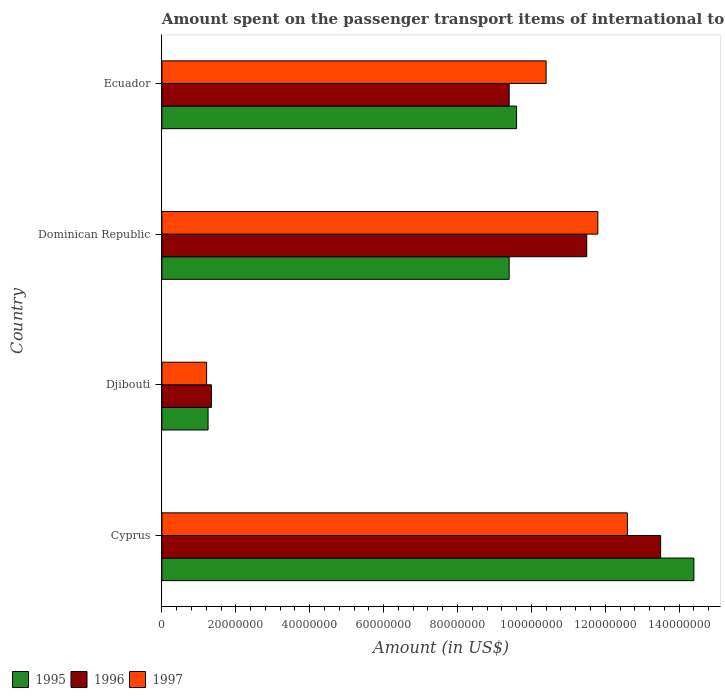How many bars are there on the 4th tick from the bottom?
Provide a succinct answer. 3. What is the label of the 2nd group of bars from the top?
Provide a succinct answer. Dominican Republic. What is the amount spent on the passenger transport items of international tourists in 1996 in Dominican Republic?
Offer a terse response. 1.15e+08. Across all countries, what is the maximum amount spent on the passenger transport items of international tourists in 1997?
Your answer should be compact. 1.26e+08. Across all countries, what is the minimum amount spent on the passenger transport items of international tourists in 1996?
Provide a short and direct response. 1.34e+07. In which country was the amount spent on the passenger transport items of international tourists in 1995 maximum?
Provide a short and direct response. Cyprus. In which country was the amount spent on the passenger transport items of international tourists in 1996 minimum?
Ensure brevity in your answer.  Djibouti. What is the total amount spent on the passenger transport items of international tourists in 1995 in the graph?
Offer a very short reply. 3.46e+08. What is the difference between the amount spent on the passenger transport items of international tourists in 1996 in Djibouti and that in Ecuador?
Provide a succinct answer. -8.06e+07. What is the difference between the amount spent on the passenger transport items of international tourists in 1997 in Cyprus and the amount spent on the passenger transport items of international tourists in 1996 in Dominican Republic?
Offer a terse response. 1.10e+07. What is the average amount spent on the passenger transport items of international tourists in 1997 per country?
Give a very brief answer. 9.00e+07. What is the difference between the amount spent on the passenger transport items of international tourists in 1997 and amount spent on the passenger transport items of international tourists in 1995 in Dominican Republic?
Keep it short and to the point. 2.40e+07. What is the ratio of the amount spent on the passenger transport items of international tourists in 1997 in Djibouti to that in Ecuador?
Your answer should be compact. 0.12. Is the amount spent on the passenger transport items of international tourists in 1996 in Cyprus less than that in Dominican Republic?
Make the answer very short. No. Is the difference between the amount spent on the passenger transport items of international tourists in 1997 in Djibouti and Ecuador greater than the difference between the amount spent on the passenger transport items of international tourists in 1995 in Djibouti and Ecuador?
Offer a very short reply. No. What is the difference between the highest and the second highest amount spent on the passenger transport items of international tourists in 1995?
Offer a terse response. 4.80e+07. What is the difference between the highest and the lowest amount spent on the passenger transport items of international tourists in 1997?
Offer a terse response. 1.14e+08. Is the sum of the amount spent on the passenger transport items of international tourists in 1995 in Djibouti and Ecuador greater than the maximum amount spent on the passenger transport items of international tourists in 1996 across all countries?
Your answer should be compact. No. How many countries are there in the graph?
Give a very brief answer. 4. What is the difference between two consecutive major ticks on the X-axis?
Offer a terse response. 2.00e+07. Are the values on the major ticks of X-axis written in scientific E-notation?
Keep it short and to the point. No. Does the graph contain any zero values?
Ensure brevity in your answer.  No. Does the graph contain grids?
Provide a short and direct response. No. How many legend labels are there?
Ensure brevity in your answer.  3. How are the legend labels stacked?
Make the answer very short. Horizontal. What is the title of the graph?
Offer a very short reply. Amount spent on the passenger transport items of international tourists. Does "1969" appear as one of the legend labels in the graph?
Make the answer very short. No. What is the Amount (in US$) of 1995 in Cyprus?
Provide a succinct answer. 1.44e+08. What is the Amount (in US$) of 1996 in Cyprus?
Your answer should be very brief. 1.35e+08. What is the Amount (in US$) of 1997 in Cyprus?
Your answer should be very brief. 1.26e+08. What is the Amount (in US$) in 1995 in Djibouti?
Keep it short and to the point. 1.25e+07. What is the Amount (in US$) of 1996 in Djibouti?
Offer a very short reply. 1.34e+07. What is the Amount (in US$) in 1997 in Djibouti?
Keep it short and to the point. 1.21e+07. What is the Amount (in US$) in 1995 in Dominican Republic?
Your answer should be very brief. 9.40e+07. What is the Amount (in US$) of 1996 in Dominican Republic?
Keep it short and to the point. 1.15e+08. What is the Amount (in US$) of 1997 in Dominican Republic?
Provide a succinct answer. 1.18e+08. What is the Amount (in US$) in 1995 in Ecuador?
Give a very brief answer. 9.60e+07. What is the Amount (in US$) of 1996 in Ecuador?
Keep it short and to the point. 9.40e+07. What is the Amount (in US$) of 1997 in Ecuador?
Make the answer very short. 1.04e+08. Across all countries, what is the maximum Amount (in US$) in 1995?
Your answer should be compact. 1.44e+08. Across all countries, what is the maximum Amount (in US$) of 1996?
Offer a very short reply. 1.35e+08. Across all countries, what is the maximum Amount (in US$) of 1997?
Your answer should be very brief. 1.26e+08. Across all countries, what is the minimum Amount (in US$) of 1995?
Offer a terse response. 1.25e+07. Across all countries, what is the minimum Amount (in US$) in 1996?
Keep it short and to the point. 1.34e+07. Across all countries, what is the minimum Amount (in US$) of 1997?
Offer a terse response. 1.21e+07. What is the total Amount (in US$) in 1995 in the graph?
Make the answer very short. 3.46e+08. What is the total Amount (in US$) in 1996 in the graph?
Your response must be concise. 3.57e+08. What is the total Amount (in US$) of 1997 in the graph?
Offer a very short reply. 3.60e+08. What is the difference between the Amount (in US$) in 1995 in Cyprus and that in Djibouti?
Give a very brief answer. 1.32e+08. What is the difference between the Amount (in US$) of 1996 in Cyprus and that in Djibouti?
Keep it short and to the point. 1.22e+08. What is the difference between the Amount (in US$) of 1997 in Cyprus and that in Djibouti?
Your response must be concise. 1.14e+08. What is the difference between the Amount (in US$) of 1995 in Cyprus and that in Ecuador?
Your answer should be very brief. 4.80e+07. What is the difference between the Amount (in US$) in 1996 in Cyprus and that in Ecuador?
Ensure brevity in your answer.  4.10e+07. What is the difference between the Amount (in US$) of 1997 in Cyprus and that in Ecuador?
Make the answer very short. 2.20e+07. What is the difference between the Amount (in US$) of 1995 in Djibouti and that in Dominican Republic?
Give a very brief answer. -8.15e+07. What is the difference between the Amount (in US$) of 1996 in Djibouti and that in Dominican Republic?
Ensure brevity in your answer.  -1.02e+08. What is the difference between the Amount (in US$) of 1997 in Djibouti and that in Dominican Republic?
Keep it short and to the point. -1.06e+08. What is the difference between the Amount (in US$) in 1995 in Djibouti and that in Ecuador?
Ensure brevity in your answer.  -8.35e+07. What is the difference between the Amount (in US$) of 1996 in Djibouti and that in Ecuador?
Your answer should be compact. -8.06e+07. What is the difference between the Amount (in US$) in 1997 in Djibouti and that in Ecuador?
Offer a very short reply. -9.19e+07. What is the difference between the Amount (in US$) in 1995 in Dominican Republic and that in Ecuador?
Make the answer very short. -2.00e+06. What is the difference between the Amount (in US$) in 1996 in Dominican Republic and that in Ecuador?
Ensure brevity in your answer.  2.10e+07. What is the difference between the Amount (in US$) of 1997 in Dominican Republic and that in Ecuador?
Your response must be concise. 1.40e+07. What is the difference between the Amount (in US$) in 1995 in Cyprus and the Amount (in US$) in 1996 in Djibouti?
Make the answer very short. 1.31e+08. What is the difference between the Amount (in US$) of 1995 in Cyprus and the Amount (in US$) of 1997 in Djibouti?
Provide a succinct answer. 1.32e+08. What is the difference between the Amount (in US$) of 1996 in Cyprus and the Amount (in US$) of 1997 in Djibouti?
Your answer should be very brief. 1.23e+08. What is the difference between the Amount (in US$) in 1995 in Cyprus and the Amount (in US$) in 1996 in Dominican Republic?
Provide a short and direct response. 2.90e+07. What is the difference between the Amount (in US$) in 1995 in Cyprus and the Amount (in US$) in 1997 in Dominican Republic?
Offer a terse response. 2.60e+07. What is the difference between the Amount (in US$) of 1996 in Cyprus and the Amount (in US$) of 1997 in Dominican Republic?
Your answer should be compact. 1.70e+07. What is the difference between the Amount (in US$) in 1995 in Cyprus and the Amount (in US$) in 1996 in Ecuador?
Offer a very short reply. 5.00e+07. What is the difference between the Amount (in US$) in 1995 in Cyprus and the Amount (in US$) in 1997 in Ecuador?
Your answer should be very brief. 4.00e+07. What is the difference between the Amount (in US$) of 1996 in Cyprus and the Amount (in US$) of 1997 in Ecuador?
Offer a terse response. 3.10e+07. What is the difference between the Amount (in US$) of 1995 in Djibouti and the Amount (in US$) of 1996 in Dominican Republic?
Provide a short and direct response. -1.02e+08. What is the difference between the Amount (in US$) of 1995 in Djibouti and the Amount (in US$) of 1997 in Dominican Republic?
Offer a terse response. -1.06e+08. What is the difference between the Amount (in US$) in 1996 in Djibouti and the Amount (in US$) in 1997 in Dominican Republic?
Your response must be concise. -1.05e+08. What is the difference between the Amount (in US$) in 1995 in Djibouti and the Amount (in US$) in 1996 in Ecuador?
Ensure brevity in your answer.  -8.15e+07. What is the difference between the Amount (in US$) of 1995 in Djibouti and the Amount (in US$) of 1997 in Ecuador?
Your response must be concise. -9.15e+07. What is the difference between the Amount (in US$) of 1996 in Djibouti and the Amount (in US$) of 1997 in Ecuador?
Provide a short and direct response. -9.06e+07. What is the difference between the Amount (in US$) of 1995 in Dominican Republic and the Amount (in US$) of 1996 in Ecuador?
Give a very brief answer. 0. What is the difference between the Amount (in US$) in 1995 in Dominican Republic and the Amount (in US$) in 1997 in Ecuador?
Provide a short and direct response. -1.00e+07. What is the difference between the Amount (in US$) in 1996 in Dominican Republic and the Amount (in US$) in 1997 in Ecuador?
Give a very brief answer. 1.10e+07. What is the average Amount (in US$) in 1995 per country?
Ensure brevity in your answer.  8.66e+07. What is the average Amount (in US$) in 1996 per country?
Keep it short and to the point. 8.94e+07. What is the average Amount (in US$) of 1997 per country?
Give a very brief answer. 9.00e+07. What is the difference between the Amount (in US$) of 1995 and Amount (in US$) of 1996 in Cyprus?
Give a very brief answer. 9.00e+06. What is the difference between the Amount (in US$) in 1995 and Amount (in US$) in 1997 in Cyprus?
Give a very brief answer. 1.80e+07. What is the difference between the Amount (in US$) in 1996 and Amount (in US$) in 1997 in Cyprus?
Provide a succinct answer. 9.00e+06. What is the difference between the Amount (in US$) in 1995 and Amount (in US$) in 1996 in Djibouti?
Provide a succinct answer. -9.00e+05. What is the difference between the Amount (in US$) of 1995 and Amount (in US$) of 1997 in Djibouti?
Your response must be concise. 4.00e+05. What is the difference between the Amount (in US$) in 1996 and Amount (in US$) in 1997 in Djibouti?
Your answer should be compact. 1.30e+06. What is the difference between the Amount (in US$) in 1995 and Amount (in US$) in 1996 in Dominican Republic?
Give a very brief answer. -2.10e+07. What is the difference between the Amount (in US$) in 1995 and Amount (in US$) in 1997 in Dominican Republic?
Provide a succinct answer. -2.40e+07. What is the difference between the Amount (in US$) of 1995 and Amount (in US$) of 1996 in Ecuador?
Ensure brevity in your answer.  2.00e+06. What is the difference between the Amount (in US$) of 1995 and Amount (in US$) of 1997 in Ecuador?
Offer a very short reply. -8.00e+06. What is the difference between the Amount (in US$) of 1996 and Amount (in US$) of 1997 in Ecuador?
Your response must be concise. -1.00e+07. What is the ratio of the Amount (in US$) of 1995 in Cyprus to that in Djibouti?
Provide a short and direct response. 11.52. What is the ratio of the Amount (in US$) of 1996 in Cyprus to that in Djibouti?
Offer a very short reply. 10.07. What is the ratio of the Amount (in US$) of 1997 in Cyprus to that in Djibouti?
Your answer should be compact. 10.41. What is the ratio of the Amount (in US$) of 1995 in Cyprus to that in Dominican Republic?
Give a very brief answer. 1.53. What is the ratio of the Amount (in US$) in 1996 in Cyprus to that in Dominican Republic?
Your response must be concise. 1.17. What is the ratio of the Amount (in US$) in 1997 in Cyprus to that in Dominican Republic?
Offer a terse response. 1.07. What is the ratio of the Amount (in US$) in 1996 in Cyprus to that in Ecuador?
Provide a succinct answer. 1.44. What is the ratio of the Amount (in US$) of 1997 in Cyprus to that in Ecuador?
Offer a very short reply. 1.21. What is the ratio of the Amount (in US$) of 1995 in Djibouti to that in Dominican Republic?
Provide a short and direct response. 0.13. What is the ratio of the Amount (in US$) of 1996 in Djibouti to that in Dominican Republic?
Your answer should be compact. 0.12. What is the ratio of the Amount (in US$) in 1997 in Djibouti to that in Dominican Republic?
Give a very brief answer. 0.1. What is the ratio of the Amount (in US$) in 1995 in Djibouti to that in Ecuador?
Offer a very short reply. 0.13. What is the ratio of the Amount (in US$) in 1996 in Djibouti to that in Ecuador?
Ensure brevity in your answer.  0.14. What is the ratio of the Amount (in US$) in 1997 in Djibouti to that in Ecuador?
Provide a succinct answer. 0.12. What is the ratio of the Amount (in US$) in 1995 in Dominican Republic to that in Ecuador?
Your answer should be compact. 0.98. What is the ratio of the Amount (in US$) in 1996 in Dominican Republic to that in Ecuador?
Provide a succinct answer. 1.22. What is the ratio of the Amount (in US$) in 1997 in Dominican Republic to that in Ecuador?
Your answer should be very brief. 1.13. What is the difference between the highest and the second highest Amount (in US$) in 1995?
Your answer should be compact. 4.80e+07. What is the difference between the highest and the second highest Amount (in US$) in 1996?
Offer a terse response. 2.00e+07. What is the difference between the highest and the second highest Amount (in US$) in 1997?
Provide a succinct answer. 8.00e+06. What is the difference between the highest and the lowest Amount (in US$) of 1995?
Your response must be concise. 1.32e+08. What is the difference between the highest and the lowest Amount (in US$) of 1996?
Offer a very short reply. 1.22e+08. What is the difference between the highest and the lowest Amount (in US$) of 1997?
Provide a short and direct response. 1.14e+08. 